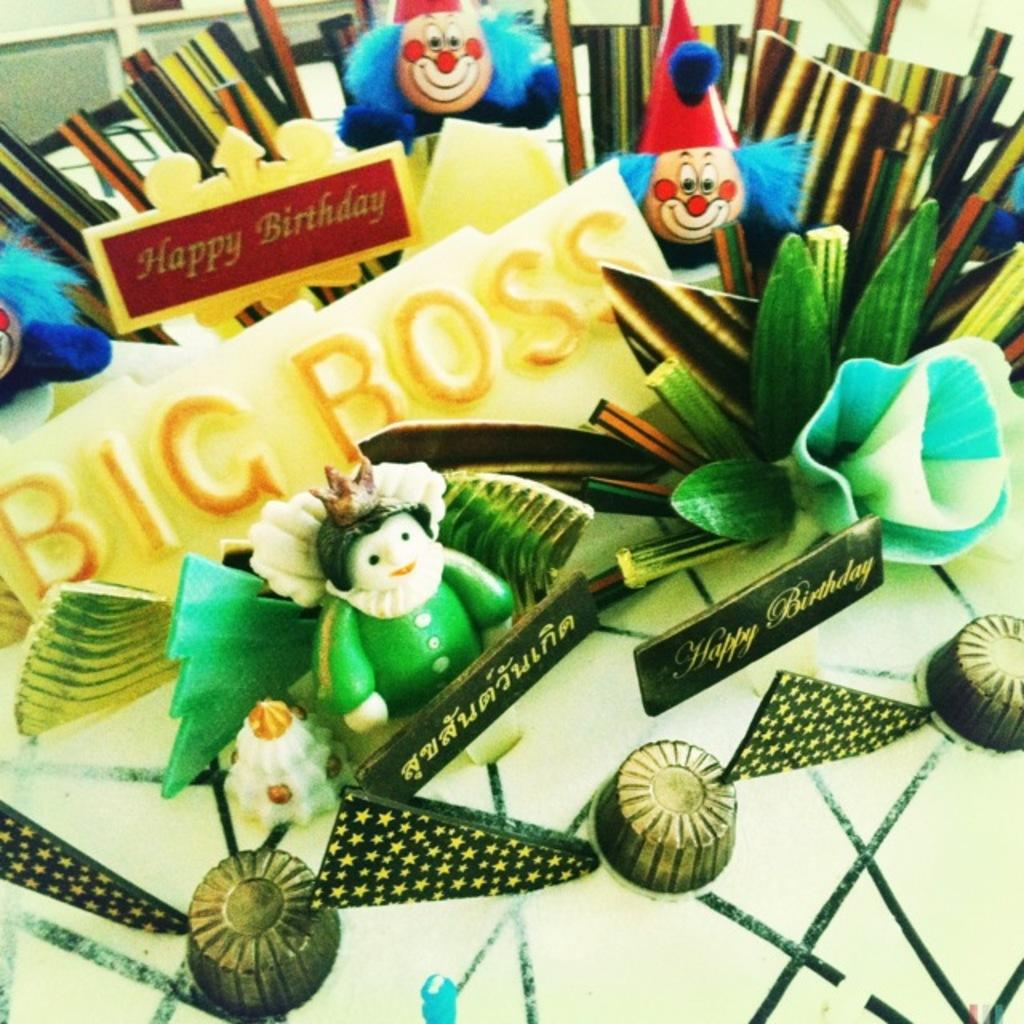What type of items are on the table in the image? There are toys and name boards on the table. Are there any other objects present on the table? Yes, there are other objects on the table. What type of motion can be observed in the image? There is no motion observable in the image, as it is a still image. Can you tell me how many apples are on the table in the image? There is no mention of apples in the provided facts, so it cannot be determined if any apples are present in the image. 